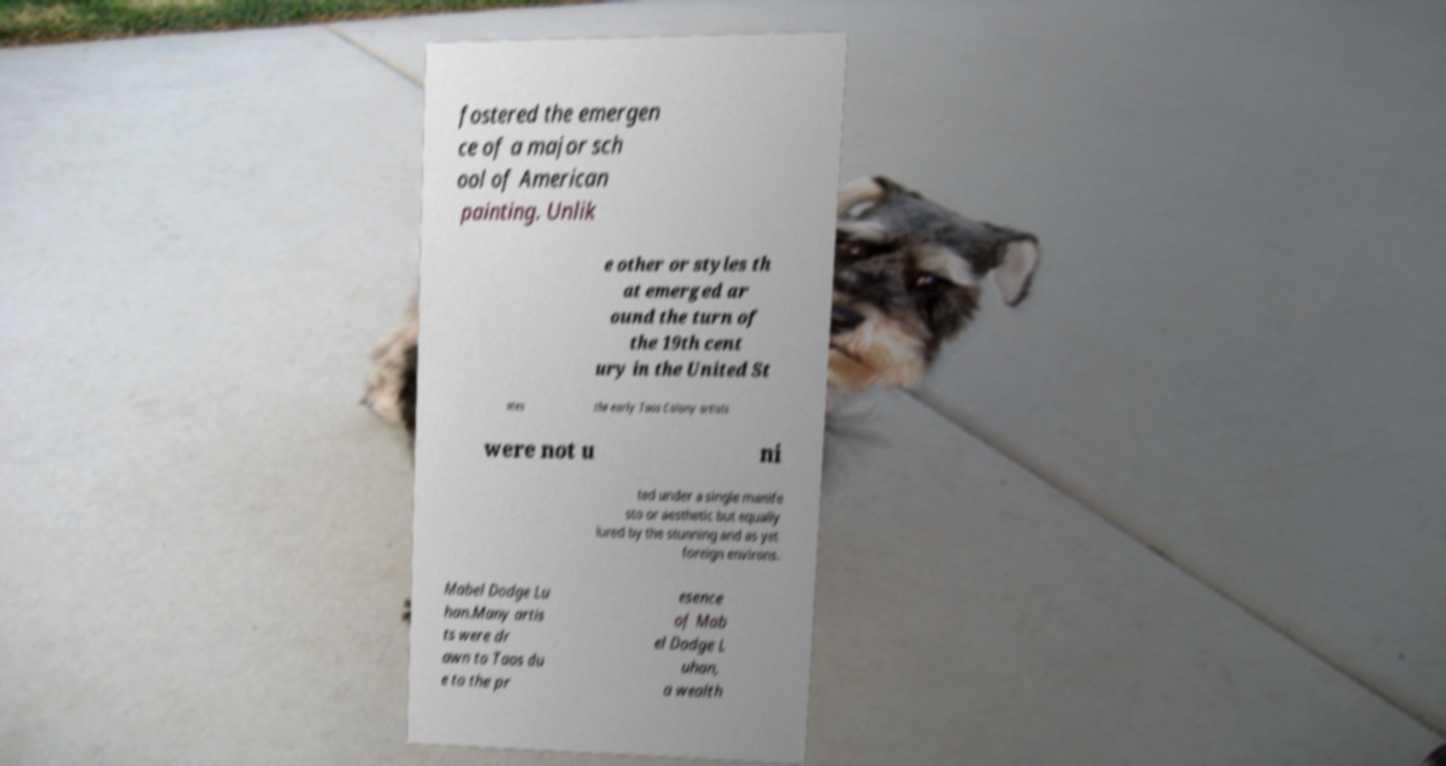Please read and relay the text visible in this image. What does it say? fostered the emergen ce of a major sch ool of American painting. Unlik e other or styles th at emerged ar ound the turn of the 19th cent ury in the United St ates the early Taos Colony artists were not u ni ted under a single manife sto or aesthetic but equally lured by the stunning and as yet foreign environs. Mabel Dodge Lu han.Many artis ts were dr awn to Taos du e to the pr esence of Mab el Dodge L uhan, a wealth 